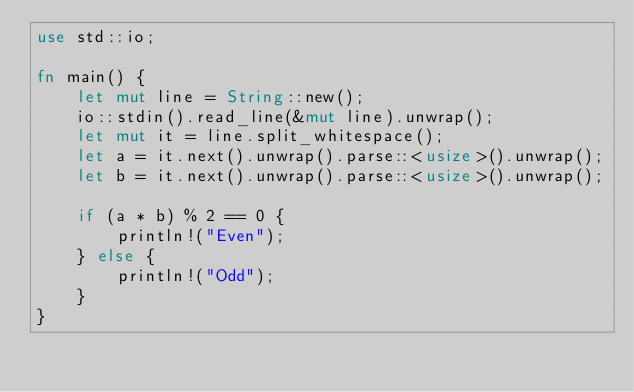Convert code to text. <code><loc_0><loc_0><loc_500><loc_500><_Rust_>use std::io;
 
fn main() {
    let mut line = String::new();
    io::stdin().read_line(&mut line).unwrap();
    let mut it = line.split_whitespace();
    let a = it.next().unwrap().parse::<usize>().unwrap();
    let b = it.next().unwrap().parse::<usize>().unwrap();
 
    if (a * b) % 2 == 0 {
        println!("Even");
    } else {
        println!("Odd");
    }
}</code> 